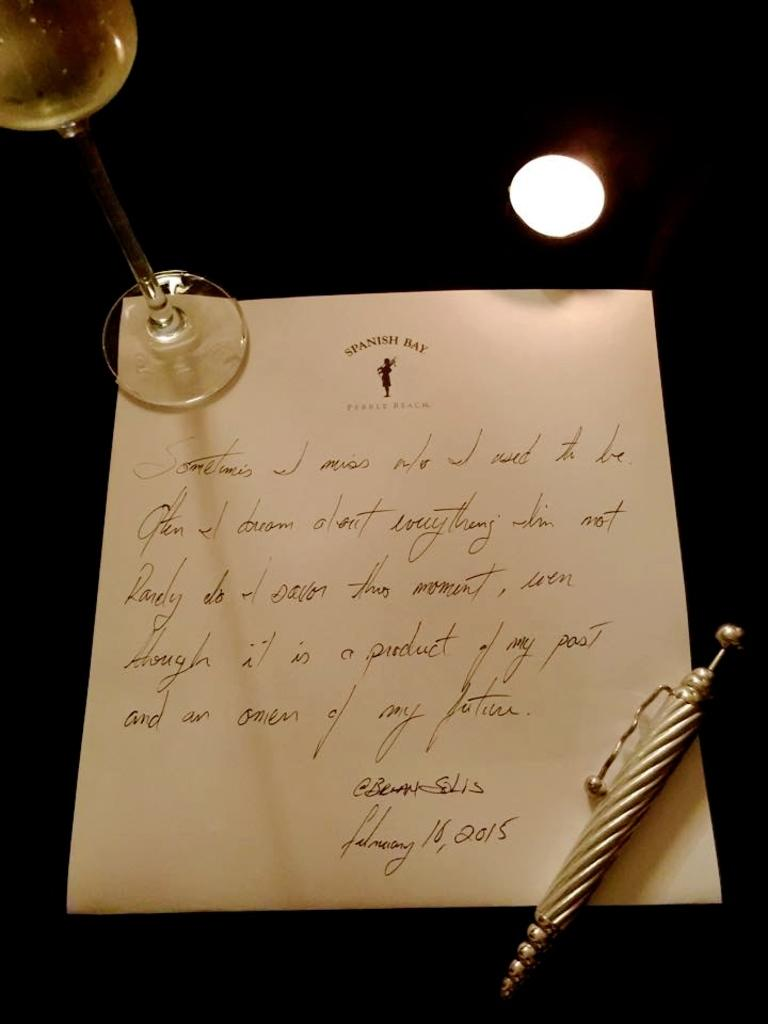What object is used for writing in the image? There is a pen in the image. What is the pen placed on in the image? There is a paper in the image. What object is used for drinking in the image? There is a glass in the image. What can be seen providing light in the background of the image? There is a light source in the background of the image. How many chickens are visible in the image? There are no chickens present in the image. What type of ink is being used in the pen in the image? The image does not provide information about the type of ink being used in the pen. 